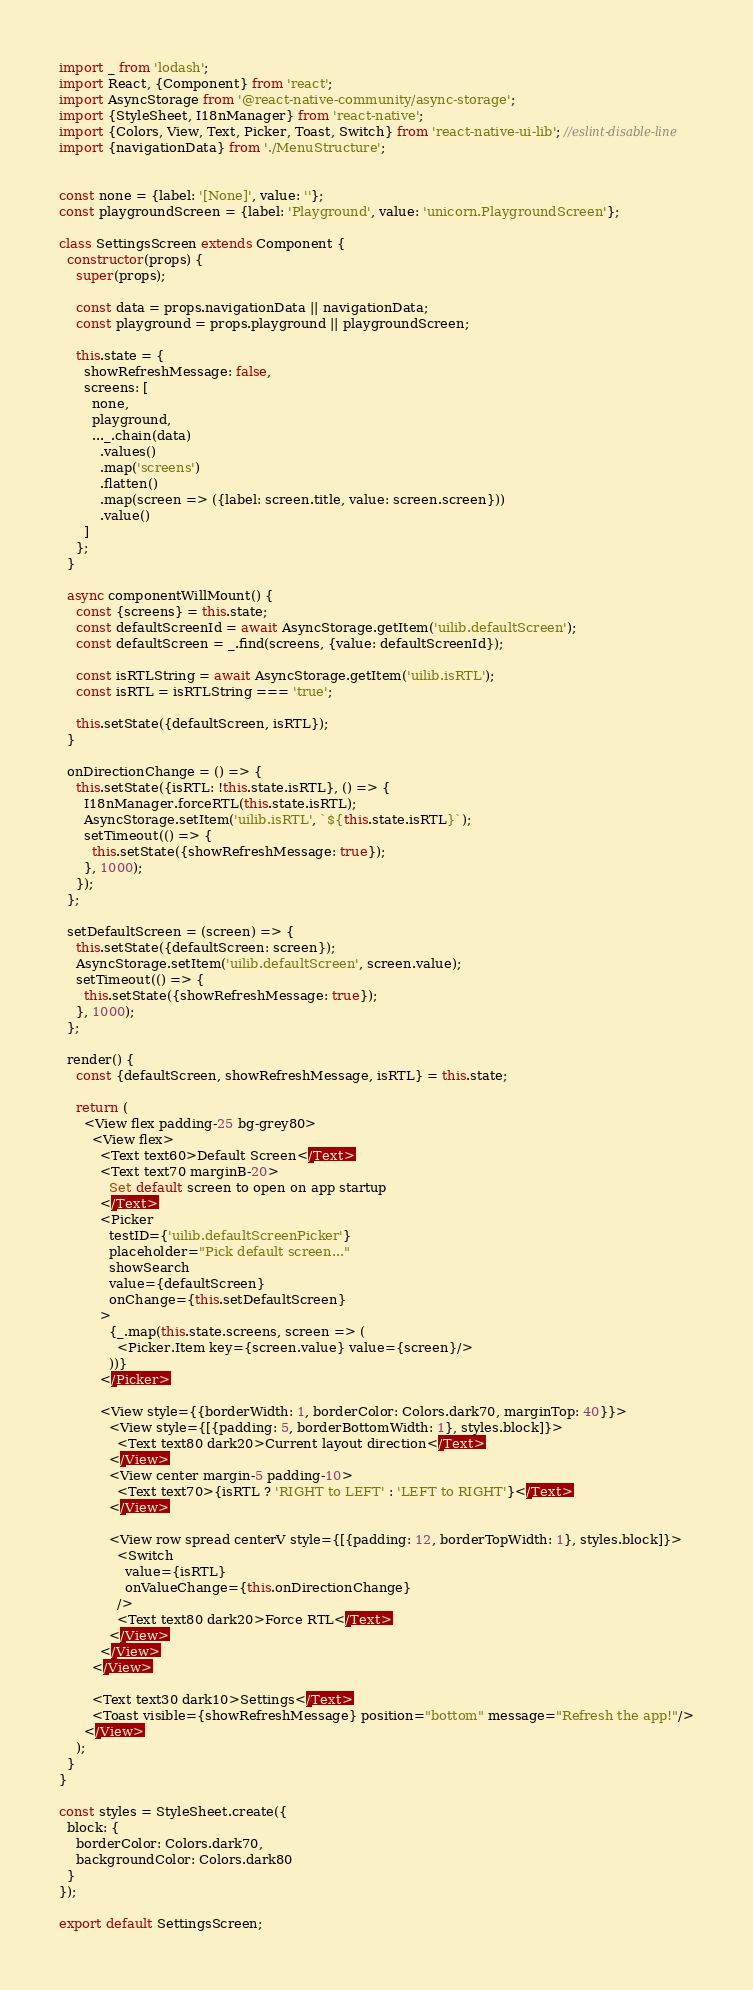Convert code to text. <code><loc_0><loc_0><loc_500><loc_500><_JavaScript_>import _ from 'lodash';
import React, {Component} from 'react';
import AsyncStorage from '@react-native-community/async-storage';
import {StyleSheet, I18nManager} from 'react-native';
import {Colors, View, Text, Picker, Toast, Switch} from 'react-native-ui-lib'; //eslint-disable-line
import {navigationData} from './MenuStructure';


const none = {label: '[None]', value: ''};
const playgroundScreen = {label: 'Playground', value: 'unicorn.PlaygroundScreen'};

class SettingsScreen extends Component {
  constructor(props) {
    super(props);

    const data = props.navigationData || navigationData;
    const playground = props.playground || playgroundScreen;
    
    this.state = {
      showRefreshMessage: false,
      screens: [
        none,
        playground,
        ..._.chain(data)
          .values()
          .map('screens')
          .flatten()
          .map(screen => ({label: screen.title, value: screen.screen}))
          .value()
      ]
    };
  }

  async componentWillMount() {
    const {screens} = this.state;
    const defaultScreenId = await AsyncStorage.getItem('uilib.defaultScreen');
    const defaultScreen = _.find(screens, {value: defaultScreenId});
    
    const isRTLString = await AsyncStorage.getItem('uilib.isRTL');
    const isRTL = isRTLString === 'true';
    
    this.setState({defaultScreen, isRTL});
  }

  onDirectionChange = () => {
    this.setState({isRTL: !this.state.isRTL}, () => {
      I18nManager.forceRTL(this.state.isRTL);
      AsyncStorage.setItem('uilib.isRTL', `${this.state.isRTL}`);
      setTimeout(() => {
        this.setState({showRefreshMessage: true});
      }, 1000);
    });
  };

  setDefaultScreen = (screen) => {
    this.setState({defaultScreen: screen});
    AsyncStorage.setItem('uilib.defaultScreen', screen.value);
    setTimeout(() => {
      this.setState({showRefreshMessage: true});
    }, 1000);
  };

  render() {
    const {defaultScreen, showRefreshMessage, isRTL} = this.state;

    return (
      <View flex padding-25 bg-grey80>
        <View flex>
          <Text text60>Default Screen</Text>
          <Text text70 marginB-20>
            Set default screen to open on app startup
          </Text>
          <Picker
            testID={'uilib.defaultScreenPicker'}
            placeholder="Pick default screen..."
            showSearch
            value={defaultScreen}
            onChange={this.setDefaultScreen}
          >
            {_.map(this.state.screens, screen => (
              <Picker.Item key={screen.value} value={screen}/>
            ))}
          </Picker>

          <View style={{borderWidth: 1, borderColor: Colors.dark70, marginTop: 40}}>
            <View style={[{padding: 5, borderBottomWidth: 1}, styles.block]}>
              <Text text80 dark20>Current layout direction</Text>
            </View>
            <View center margin-5 padding-10>
              <Text text70>{isRTL ? 'RIGHT to LEFT' : 'LEFT to RIGHT'}</Text>
            </View>

            <View row spread centerV style={[{padding: 12, borderTopWidth: 1}, styles.block]}>
              <Switch
                value={isRTL}
                onValueChange={this.onDirectionChange}
              />
              <Text text80 dark20>Force RTL</Text>
            </View>
          </View>
        </View>

        <Text text30 dark10>Settings</Text>
        <Toast visible={showRefreshMessage} position="bottom" message="Refresh the app!"/>
      </View>
    );
  }
}

const styles = StyleSheet.create({
  block: {
    borderColor: Colors.dark70,
    backgroundColor: Colors.dark80
  }
});

export default SettingsScreen;
</code> 